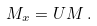Convert formula to latex. <formula><loc_0><loc_0><loc_500><loc_500>M _ { x } = U M \, .</formula> 